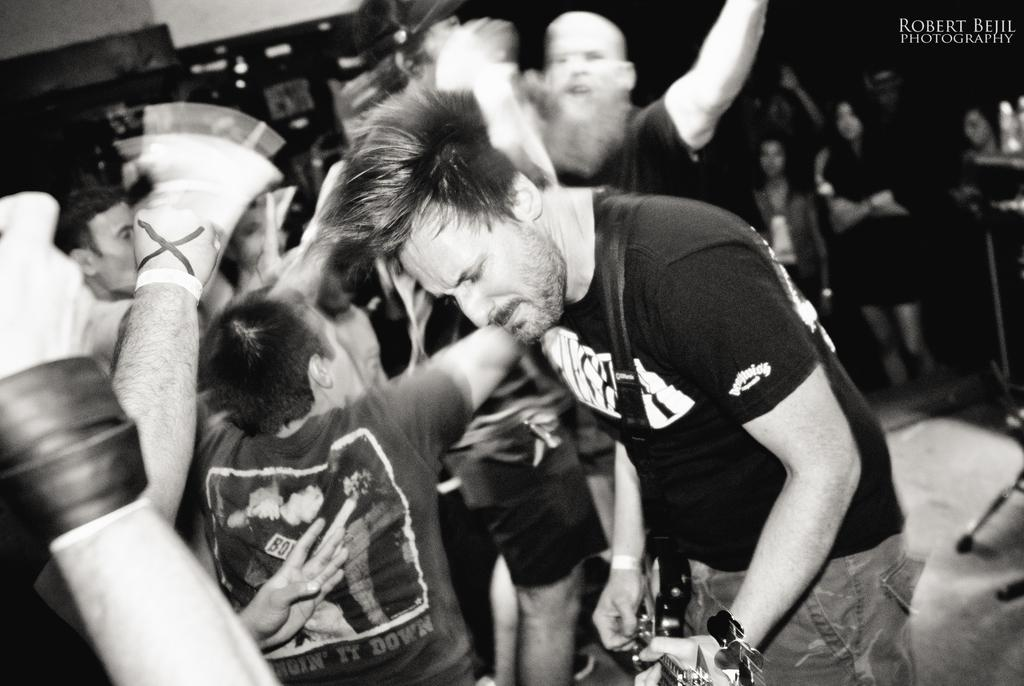What is the man in the image doing? The man is standing and playing a musical instrument in the image. What activities are happening in the background of the image? In the background, there is a person dancing and another person standing. What type of quartz can be seen in the image? There is no quartz present in the image. How many trucks are visible in the image? There are no trucks visible in the image. 